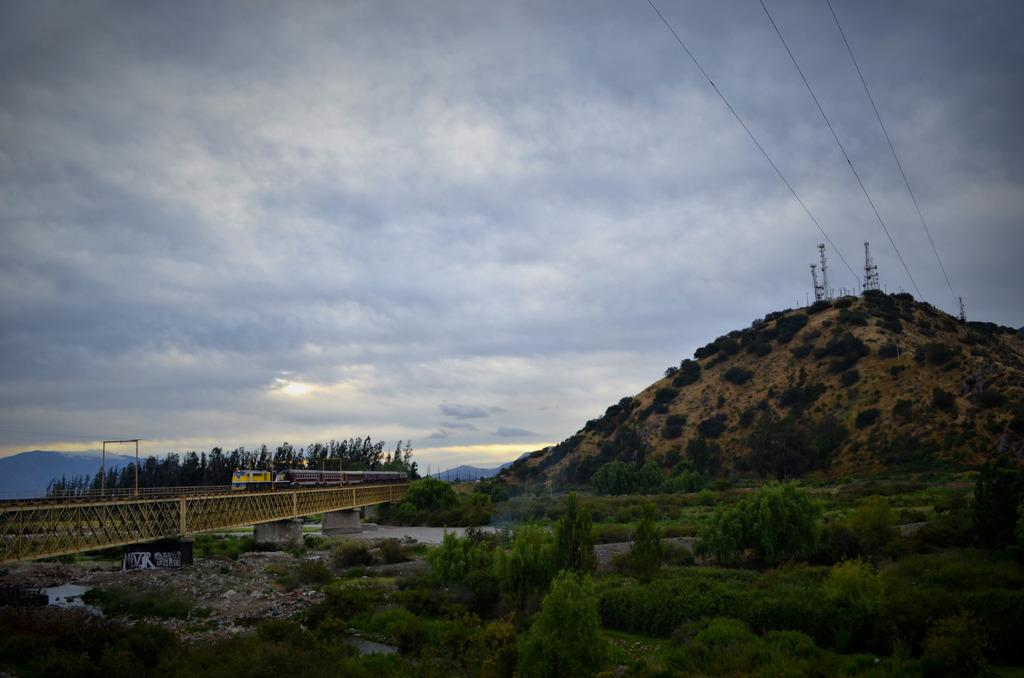What is happening in the image involving water? There is water flow in the image. What mode of transportation can be seen in the image? There is a train on the track of a bridge in the image. What type of vegetation is visible in the image? There are trees visible in the image. What type of geographical feature can be seen in the image? There are hills visible in the image. What page of the book is the train on in the image? There is no book present in the image, so it is not possible to determine which page the train is on. 